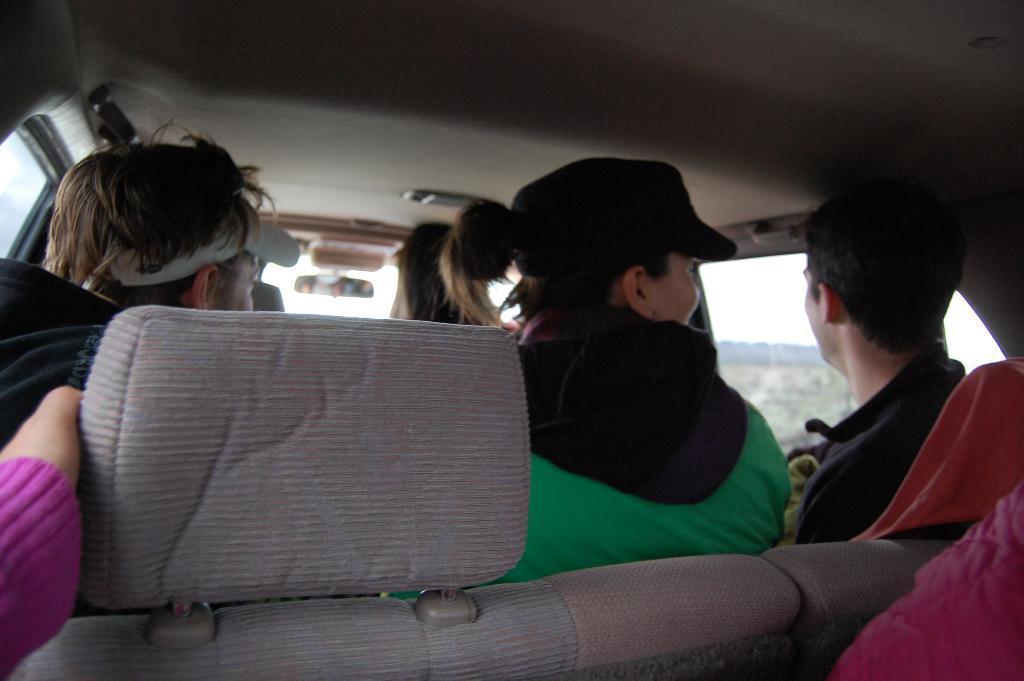Could you give a brief overview of what you see in this image? In this picture we can see inside of the vehicle, there people sitting and we can see glass window, through this glass window we can see sky. 